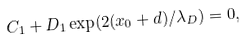Convert formula to latex. <formula><loc_0><loc_0><loc_500><loc_500>C _ { 1 } + D _ { 1 } \exp ( 2 ( x _ { 0 } + d ) / \lambda _ { D } ) = 0 ,</formula> 